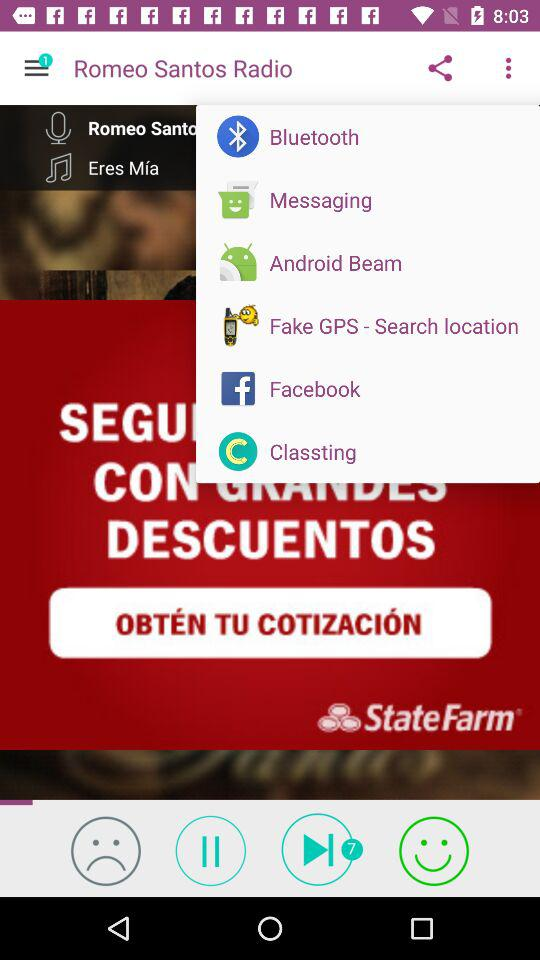What is the music name? The music name is "Eres Mía". 